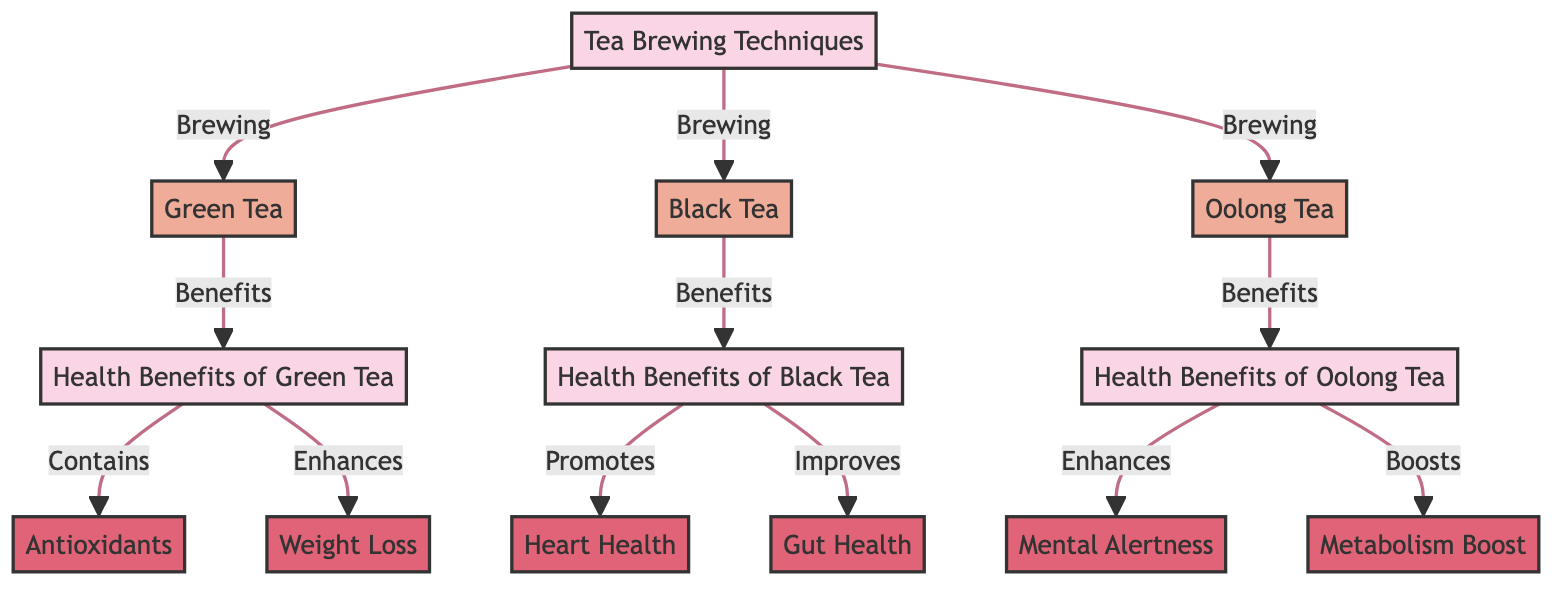What are the three tea brewing techniques listed in the diagram? The diagram explicitly lists Green Tea, Black Tea, and Oolong Tea as the three brewing techniques under the "Tea Brewing Techniques" category.
Answer: Green Tea, Black Tea, Oolong Tea How many health benefits are associated with Green Tea? The diagram shows that Green Tea has two associated health benefits: Antioxidants and Weight Loss listed under the "Health Benefits of Green Tea" category.
Answer: 2 What health benefit of Oolong Tea is related to mental health? According to the diagram, Mental Alertness is a health benefit associated with Oolong Tea, as shown in the "Health Benefits of Oolong Tea" category.
Answer: Mental Alertness Which tea brewing technique promotes heart health? The diagram indicates that Black Tea promotes heart health, as it is directly connected to the "Heart Health" benefit under the "Health Benefits of Black Tea" category.
Answer: Black Tea What is one health benefit that Black Tea improves? The diagram specifies that Black Tea improves Gut Health, making it one of the health benefits associated with this tea type.
Answer: Gut Health Which health benefit is related to metabolism and linked to Oolong Tea? The diagram asserts that Metabolism Boost is a health benefit associated with Oolong Tea, found under the "Health Benefits of Oolong Tea" category.
Answer: Metabolism Boost How many total connections (edges) are drawn in this diagram? Upon reviewing the diagram, we can see there are a total of nine connections (edges) drawn from the techniques to their respective health benefits and between the main categories.
Answer: 9 What specific health benefit of Green Tea is categorized as an antioxidant? The diagram labels Antioxidants as a specific health benefit categorized under Green Tea, clearly showing its connection.
Answer: Antioxidants 